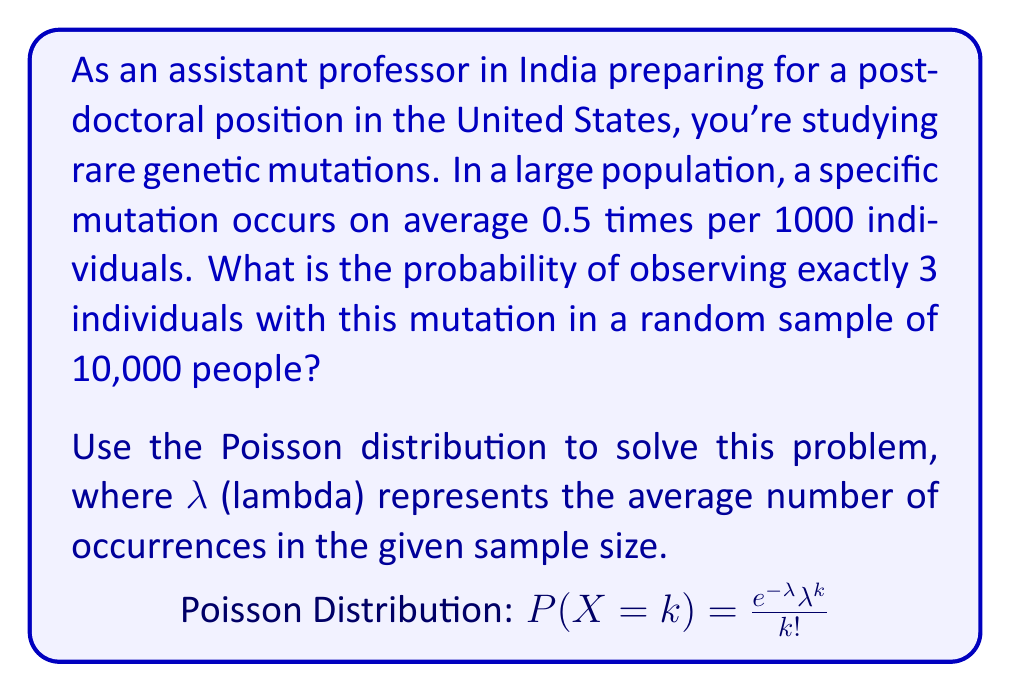What is the answer to this math problem? Let's approach this step-by-step using the Poisson distribution:

1) First, we need to calculate λ (lambda) for our sample size:
   - The mutation occurs 0.5 times per 1000 individuals
   - Our sample size is 10,000 individuals
   
   $$λ = 0.5 \times \frac{10,000}{1000} = 5$$

2) The Poisson distribution formula is:

   $$P(X = k) = \frac{e^{-λ} λ^k}{k!}$$

   Where:
   - e is Euler's number (≈ 2.71828)
   - λ is the average number of occurrences
   - k is the number of occurrences we're interested in (3 in this case)

3) Let's substitute our values:

   $$P(X = 3) = \frac{e^{-5} 5^3}{3!}$$

4) Now let's calculate:
   
   $$P(X = 3) = \frac{e^{-5} \times 125}{6}$$

5) Using a calculator:

   $$P(X = 3) ≈ \frac{0.00674 \times 125}{6} ≈ 0.1404$$

6) Convert to a percentage:

   $$0.1404 \times 100\% ≈ 14.04\%$$

Thus, the probability of observing exactly 3 individuals with this mutation in a sample of 10,000 people is approximately 14.04%.
Answer: $14.04\%$ 